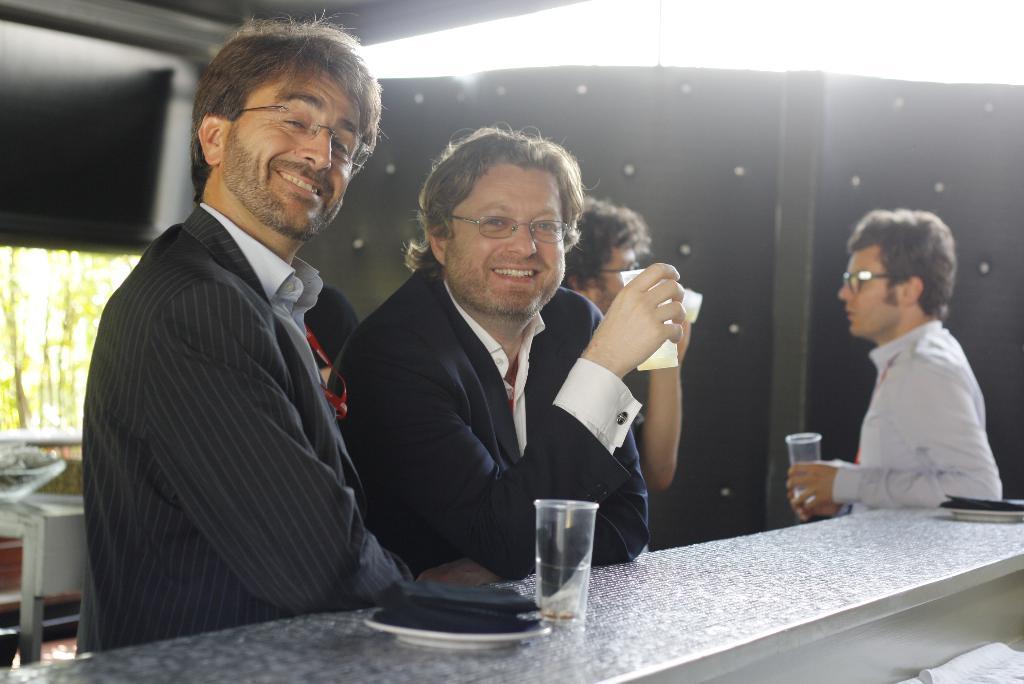Describe this image in one or two sentences. This picture is taken inside the room. In this image, we can see two men are standing, in that one man is standing and holding a glass in his hand, we can also see a table in the image. On that table, on the left side, we can see a plate, on the plate, we can see a black colored cloth. On the right side of the table, we can see a plate, on that plate, we can see a cloth. On the right side, we can also see two men are standing behind the table, in that one man is holding a glass. On the left side, we can see a table. At the top, we can see a roof with few lights. 